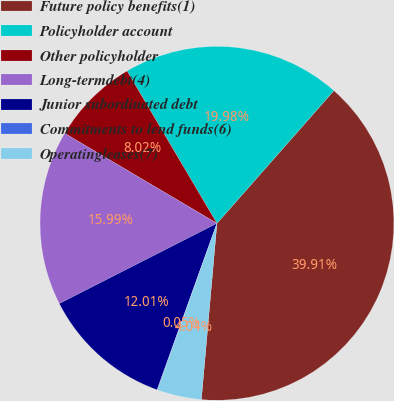Convert chart to OTSL. <chart><loc_0><loc_0><loc_500><loc_500><pie_chart><fcel>Future policy benefits(1)<fcel>Policyholder account<fcel>Other policyholder<fcel>Long-termdebt(4)<fcel>Junior subordinated debt<fcel>Commitments to lend funds(6)<fcel>Operatingleases(7)<nl><fcel>39.91%<fcel>19.98%<fcel>8.02%<fcel>15.99%<fcel>12.01%<fcel>0.05%<fcel>4.04%<nl></chart> 